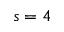Convert formula to latex. <formula><loc_0><loc_0><loc_500><loc_500>s = 4</formula> 